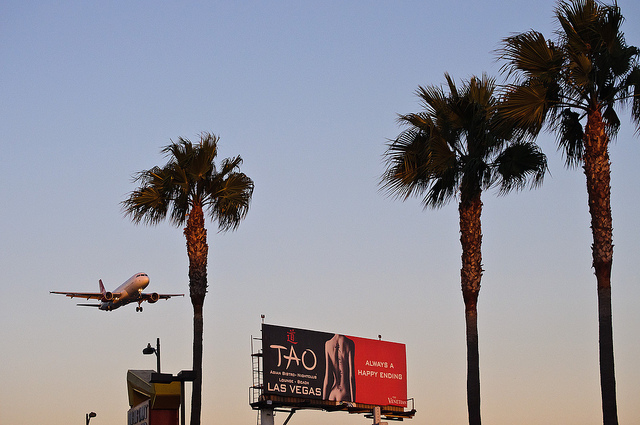Please transcribe the text in this image. TAO las VEGAS ALWAYS & happy ENDING 